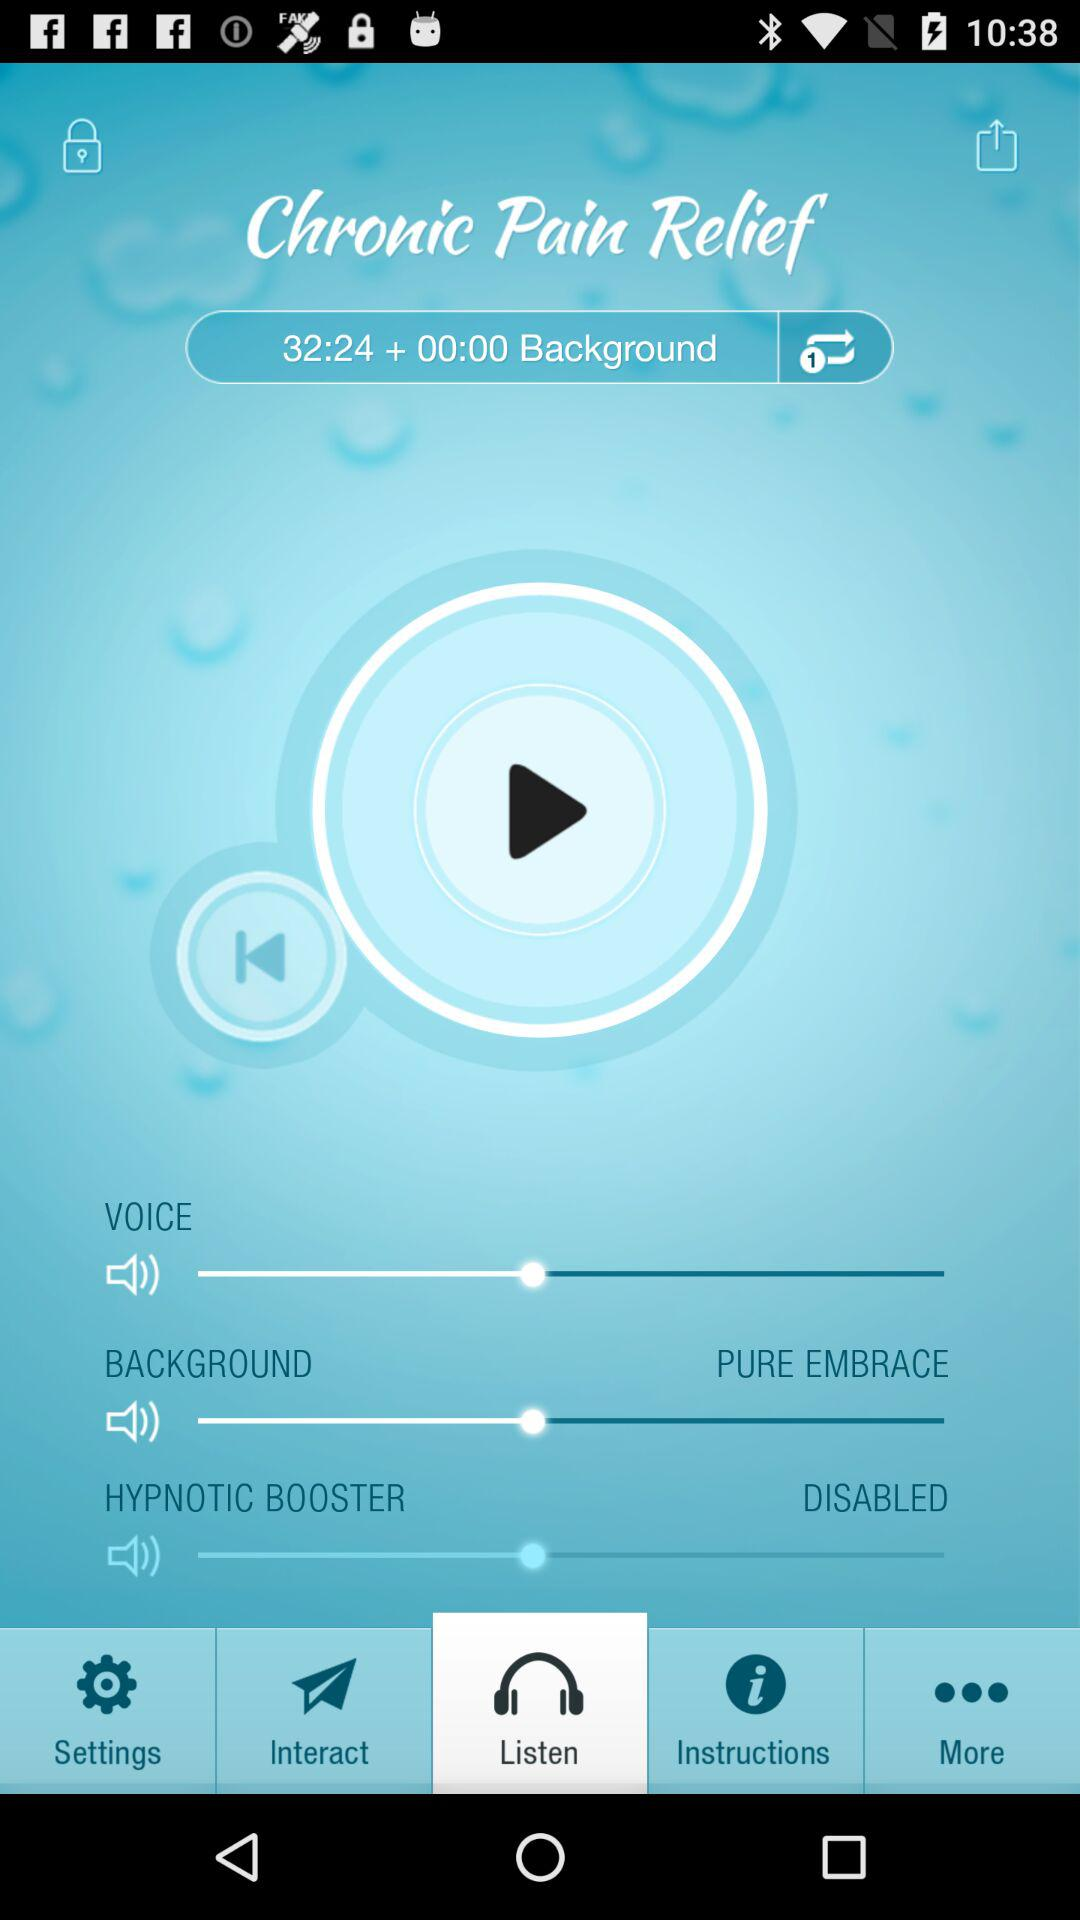What is the status of the "HYPNOTIC BOOSTER"? The status is "DISABLED". 